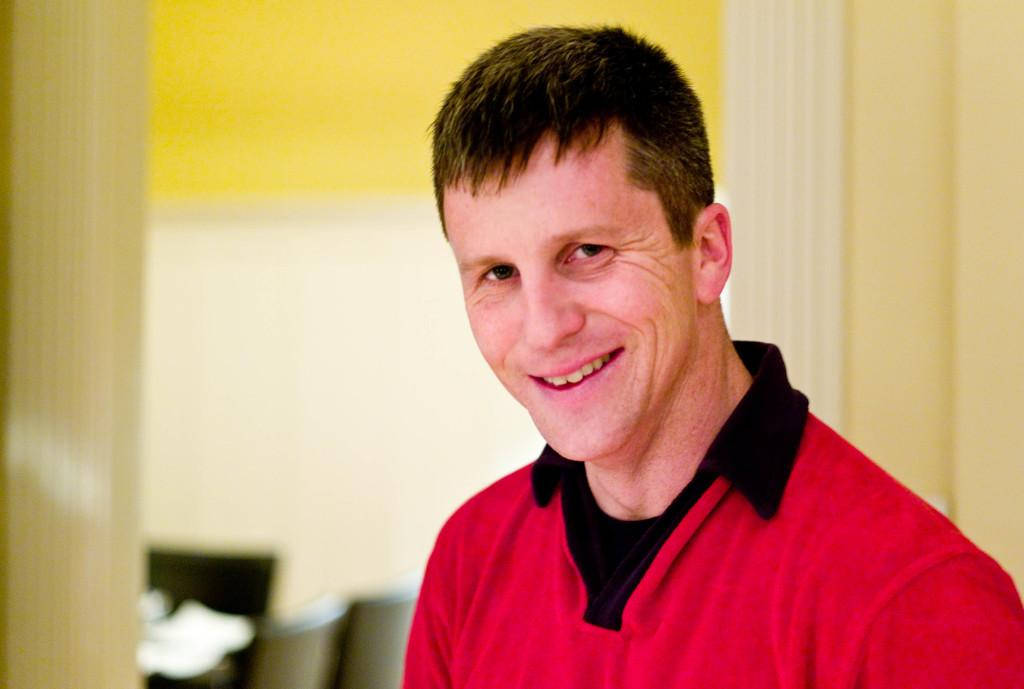Who is present in the image? There is a man in the image. What is the man wearing? The man is wearing a red shirt. What is the man's expression in the image? The man is laughing. What can be seen in the background of the image? There is a wall in the background of the image. What piece of furniture is present in the image? There is a chair in the image. What is on the chair? Papers are present on the chair. How many clocks are visible in the image? There are no clocks visible in the image. Why is the maid crying in the image? There is no maid present in the image, and no one is crying. 